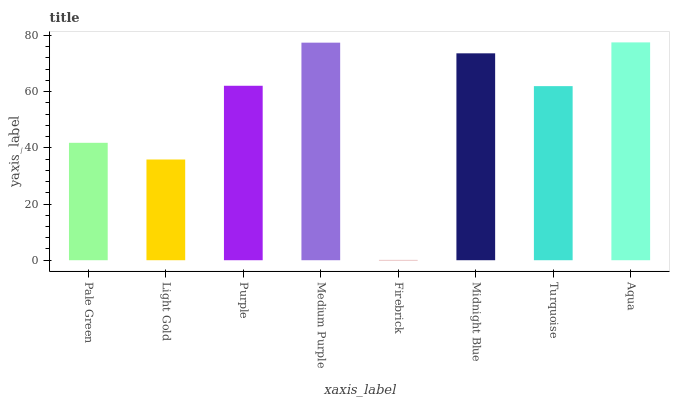Is Firebrick the minimum?
Answer yes or no. Yes. Is Aqua the maximum?
Answer yes or no. Yes. Is Light Gold the minimum?
Answer yes or no. No. Is Light Gold the maximum?
Answer yes or no. No. Is Pale Green greater than Light Gold?
Answer yes or no. Yes. Is Light Gold less than Pale Green?
Answer yes or no. Yes. Is Light Gold greater than Pale Green?
Answer yes or no. No. Is Pale Green less than Light Gold?
Answer yes or no. No. Is Purple the high median?
Answer yes or no. Yes. Is Turquoise the low median?
Answer yes or no. Yes. Is Firebrick the high median?
Answer yes or no. No. Is Firebrick the low median?
Answer yes or no. No. 